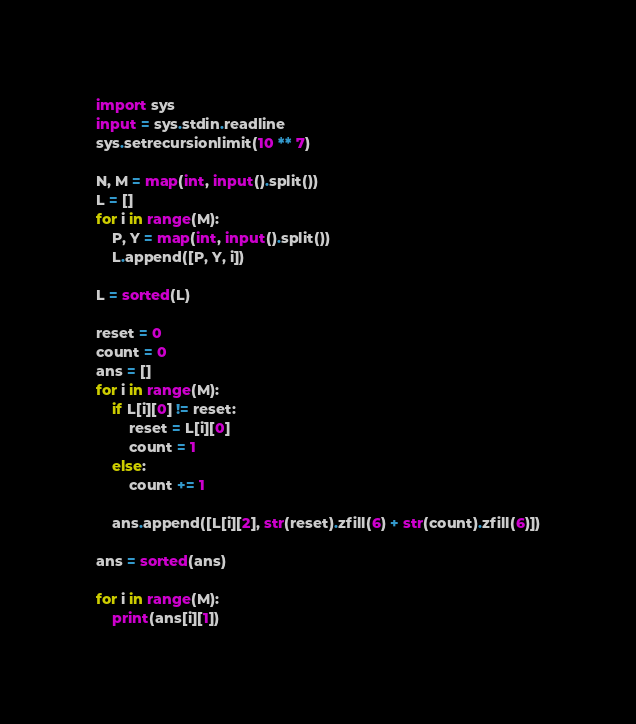Convert code to text. <code><loc_0><loc_0><loc_500><loc_500><_Python_>import sys
input = sys.stdin.readline
sys.setrecursionlimit(10 ** 7)

N, M = map(int, input().split())
L = []
for i in range(M):
    P, Y = map(int, input().split())
    L.append([P, Y, i])

L = sorted(L)

reset = 0
count = 0
ans = []
for i in range(M):
    if L[i][0] != reset:
        reset = L[i][0]
        count = 1
    else:
        count += 1
    
    ans.append([L[i][2], str(reset).zfill(6) + str(count).zfill(6)])

ans = sorted(ans)

for i in range(M):
    print(ans[i][1])</code> 